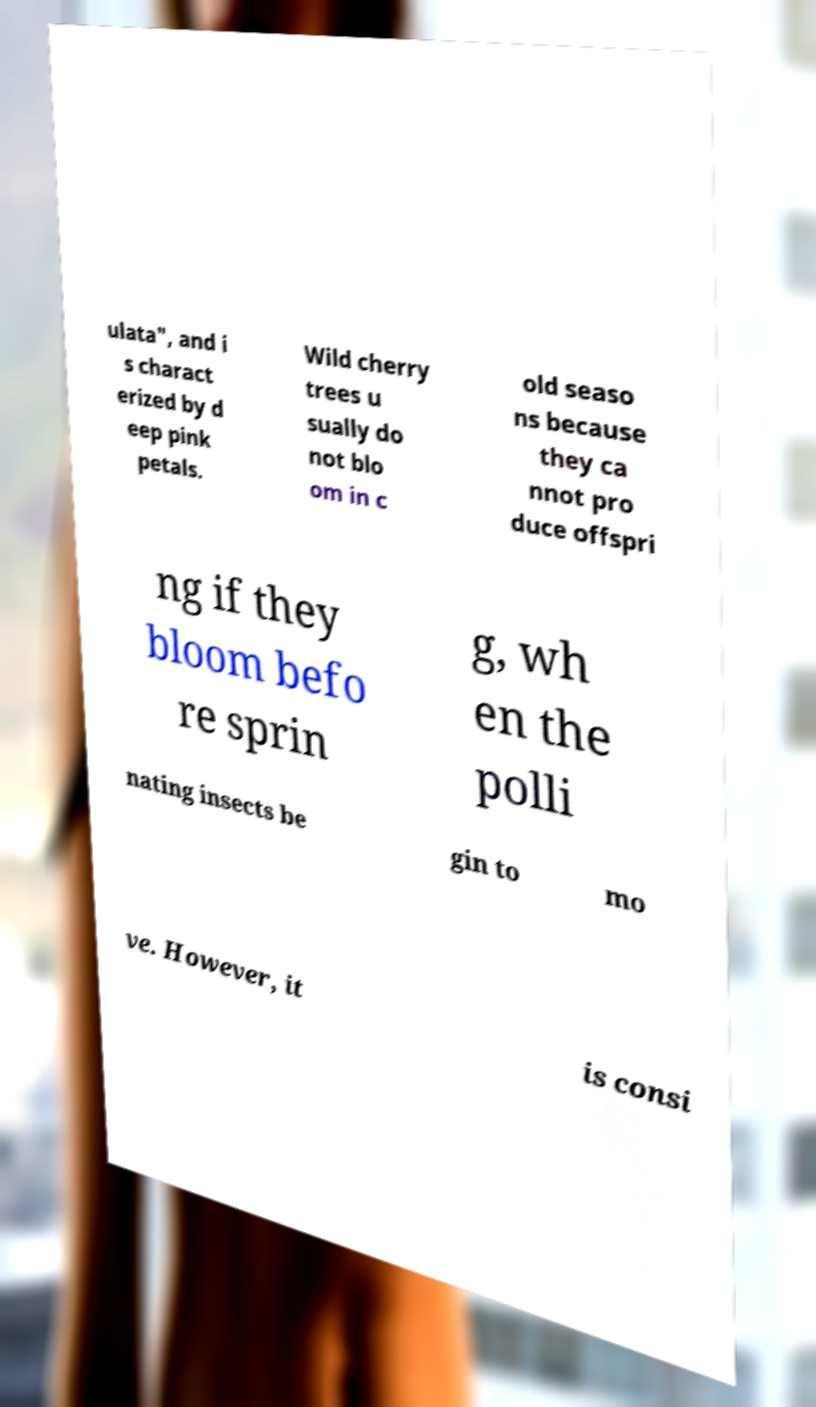Can you accurately transcribe the text from the provided image for me? ulata", and i s charact erized by d eep pink petals. Wild cherry trees u sually do not blo om in c old seaso ns because they ca nnot pro duce offspri ng if they bloom befo re sprin g, wh en the polli nating insects be gin to mo ve. However, it is consi 